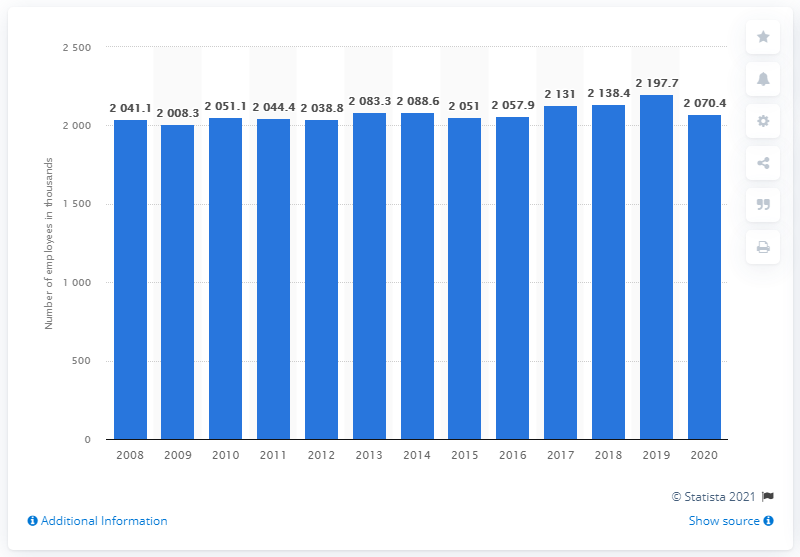Mention a couple of crucial points in this snapshot. There were 2,088.6 retail trade employees in Canada in 2020. 